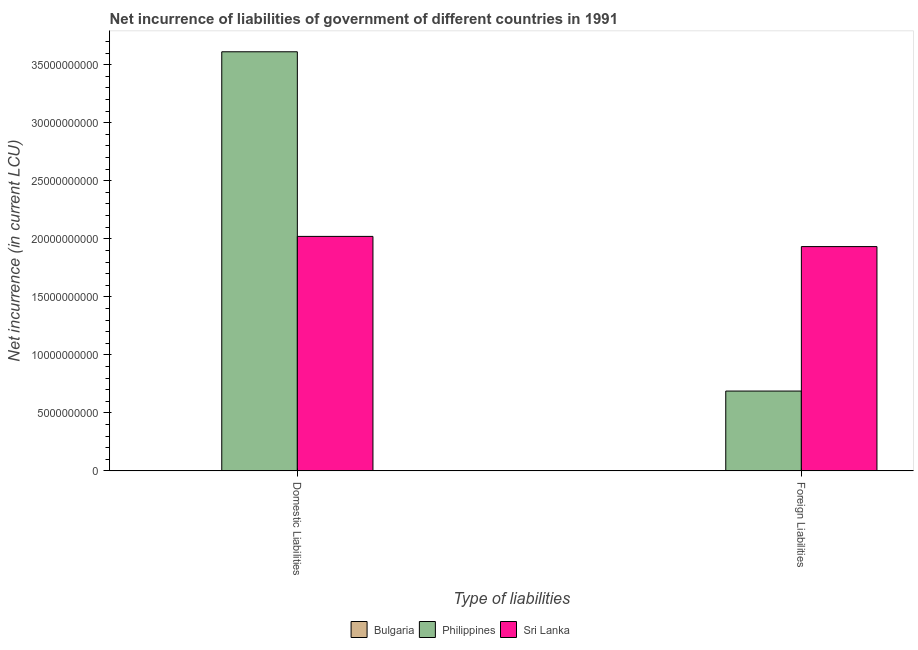How many groups of bars are there?
Give a very brief answer. 2. How many bars are there on the 1st tick from the left?
Offer a very short reply. 3. What is the label of the 2nd group of bars from the left?
Give a very brief answer. Foreign Liabilities. What is the net incurrence of domestic liabilities in Bulgaria?
Your response must be concise. 7.47e+06. Across all countries, what is the maximum net incurrence of domestic liabilities?
Offer a very short reply. 3.61e+1. Across all countries, what is the minimum net incurrence of domestic liabilities?
Offer a very short reply. 7.47e+06. What is the total net incurrence of foreign liabilities in the graph?
Give a very brief answer. 2.62e+1. What is the difference between the net incurrence of domestic liabilities in Philippines and that in Sri Lanka?
Give a very brief answer. 1.59e+1. What is the difference between the net incurrence of foreign liabilities in Bulgaria and the net incurrence of domestic liabilities in Sri Lanka?
Provide a short and direct response. -2.02e+1. What is the average net incurrence of domestic liabilities per country?
Offer a very short reply. 1.88e+1. What is the difference between the net incurrence of domestic liabilities and net incurrence of foreign liabilities in Bulgaria?
Offer a very short reply. 3.71e+06. In how many countries, is the net incurrence of foreign liabilities greater than 29000000000 LCU?
Your answer should be very brief. 0. What is the ratio of the net incurrence of foreign liabilities in Bulgaria to that in Philippines?
Provide a succinct answer. 0. Is the net incurrence of foreign liabilities in Philippines less than that in Bulgaria?
Your answer should be very brief. No. In how many countries, is the net incurrence of domestic liabilities greater than the average net incurrence of domestic liabilities taken over all countries?
Offer a terse response. 2. Are all the bars in the graph horizontal?
Offer a very short reply. No. Are the values on the major ticks of Y-axis written in scientific E-notation?
Your answer should be very brief. No. Does the graph contain any zero values?
Your answer should be compact. No. Where does the legend appear in the graph?
Your answer should be very brief. Bottom center. How many legend labels are there?
Keep it short and to the point. 3. How are the legend labels stacked?
Ensure brevity in your answer.  Horizontal. What is the title of the graph?
Provide a short and direct response. Net incurrence of liabilities of government of different countries in 1991. What is the label or title of the X-axis?
Your answer should be very brief. Type of liabilities. What is the label or title of the Y-axis?
Ensure brevity in your answer.  Net incurrence (in current LCU). What is the Net incurrence (in current LCU) of Bulgaria in Domestic Liabilities?
Your answer should be compact. 7.47e+06. What is the Net incurrence (in current LCU) in Philippines in Domestic Liabilities?
Provide a short and direct response. 3.61e+1. What is the Net incurrence (in current LCU) in Sri Lanka in Domestic Liabilities?
Make the answer very short. 2.02e+1. What is the Net incurrence (in current LCU) in Bulgaria in Foreign Liabilities?
Provide a succinct answer. 3.76e+06. What is the Net incurrence (in current LCU) in Philippines in Foreign Liabilities?
Give a very brief answer. 6.88e+09. What is the Net incurrence (in current LCU) of Sri Lanka in Foreign Liabilities?
Offer a very short reply. 1.93e+1. Across all Type of liabilities, what is the maximum Net incurrence (in current LCU) of Bulgaria?
Ensure brevity in your answer.  7.47e+06. Across all Type of liabilities, what is the maximum Net incurrence (in current LCU) in Philippines?
Your answer should be compact. 3.61e+1. Across all Type of liabilities, what is the maximum Net incurrence (in current LCU) in Sri Lanka?
Make the answer very short. 2.02e+1. Across all Type of liabilities, what is the minimum Net incurrence (in current LCU) in Bulgaria?
Your answer should be compact. 3.76e+06. Across all Type of liabilities, what is the minimum Net incurrence (in current LCU) of Philippines?
Make the answer very short. 6.88e+09. Across all Type of liabilities, what is the minimum Net incurrence (in current LCU) of Sri Lanka?
Give a very brief answer. 1.93e+1. What is the total Net incurrence (in current LCU) in Bulgaria in the graph?
Make the answer very short. 1.12e+07. What is the total Net incurrence (in current LCU) of Philippines in the graph?
Provide a short and direct response. 4.30e+1. What is the total Net incurrence (in current LCU) in Sri Lanka in the graph?
Your response must be concise. 3.95e+1. What is the difference between the Net incurrence (in current LCU) in Bulgaria in Domestic Liabilities and that in Foreign Liabilities?
Your answer should be very brief. 3.71e+06. What is the difference between the Net incurrence (in current LCU) in Philippines in Domestic Liabilities and that in Foreign Liabilities?
Keep it short and to the point. 2.92e+1. What is the difference between the Net incurrence (in current LCU) in Sri Lanka in Domestic Liabilities and that in Foreign Liabilities?
Your response must be concise. 8.78e+08. What is the difference between the Net incurrence (in current LCU) in Bulgaria in Domestic Liabilities and the Net incurrence (in current LCU) in Philippines in Foreign Liabilities?
Keep it short and to the point. -6.87e+09. What is the difference between the Net incurrence (in current LCU) of Bulgaria in Domestic Liabilities and the Net incurrence (in current LCU) of Sri Lanka in Foreign Liabilities?
Ensure brevity in your answer.  -1.93e+1. What is the difference between the Net incurrence (in current LCU) of Philippines in Domestic Liabilities and the Net incurrence (in current LCU) of Sri Lanka in Foreign Liabilities?
Your response must be concise. 1.68e+1. What is the average Net incurrence (in current LCU) in Bulgaria per Type of liabilities?
Make the answer very short. 5.62e+06. What is the average Net incurrence (in current LCU) of Philippines per Type of liabilities?
Give a very brief answer. 2.15e+1. What is the average Net incurrence (in current LCU) in Sri Lanka per Type of liabilities?
Your answer should be compact. 1.98e+1. What is the difference between the Net incurrence (in current LCU) of Bulgaria and Net incurrence (in current LCU) of Philippines in Domestic Liabilities?
Your answer should be very brief. -3.61e+1. What is the difference between the Net incurrence (in current LCU) of Bulgaria and Net incurrence (in current LCU) of Sri Lanka in Domestic Liabilities?
Ensure brevity in your answer.  -2.02e+1. What is the difference between the Net incurrence (in current LCU) of Philippines and Net incurrence (in current LCU) of Sri Lanka in Domestic Liabilities?
Make the answer very short. 1.59e+1. What is the difference between the Net incurrence (in current LCU) in Bulgaria and Net incurrence (in current LCU) in Philippines in Foreign Liabilities?
Give a very brief answer. -6.88e+09. What is the difference between the Net incurrence (in current LCU) of Bulgaria and Net incurrence (in current LCU) of Sri Lanka in Foreign Liabilities?
Provide a succinct answer. -1.93e+1. What is the difference between the Net incurrence (in current LCU) in Philippines and Net incurrence (in current LCU) in Sri Lanka in Foreign Liabilities?
Keep it short and to the point. -1.24e+1. What is the ratio of the Net incurrence (in current LCU) of Bulgaria in Domestic Liabilities to that in Foreign Liabilities?
Provide a succinct answer. 1.99. What is the ratio of the Net incurrence (in current LCU) in Philippines in Domestic Liabilities to that in Foreign Liabilities?
Make the answer very short. 5.25. What is the ratio of the Net incurrence (in current LCU) in Sri Lanka in Domestic Liabilities to that in Foreign Liabilities?
Give a very brief answer. 1.05. What is the difference between the highest and the second highest Net incurrence (in current LCU) of Bulgaria?
Keep it short and to the point. 3.71e+06. What is the difference between the highest and the second highest Net incurrence (in current LCU) in Philippines?
Your answer should be very brief. 2.92e+1. What is the difference between the highest and the second highest Net incurrence (in current LCU) of Sri Lanka?
Ensure brevity in your answer.  8.78e+08. What is the difference between the highest and the lowest Net incurrence (in current LCU) in Bulgaria?
Provide a short and direct response. 3.71e+06. What is the difference between the highest and the lowest Net incurrence (in current LCU) in Philippines?
Make the answer very short. 2.92e+1. What is the difference between the highest and the lowest Net incurrence (in current LCU) of Sri Lanka?
Your answer should be compact. 8.78e+08. 